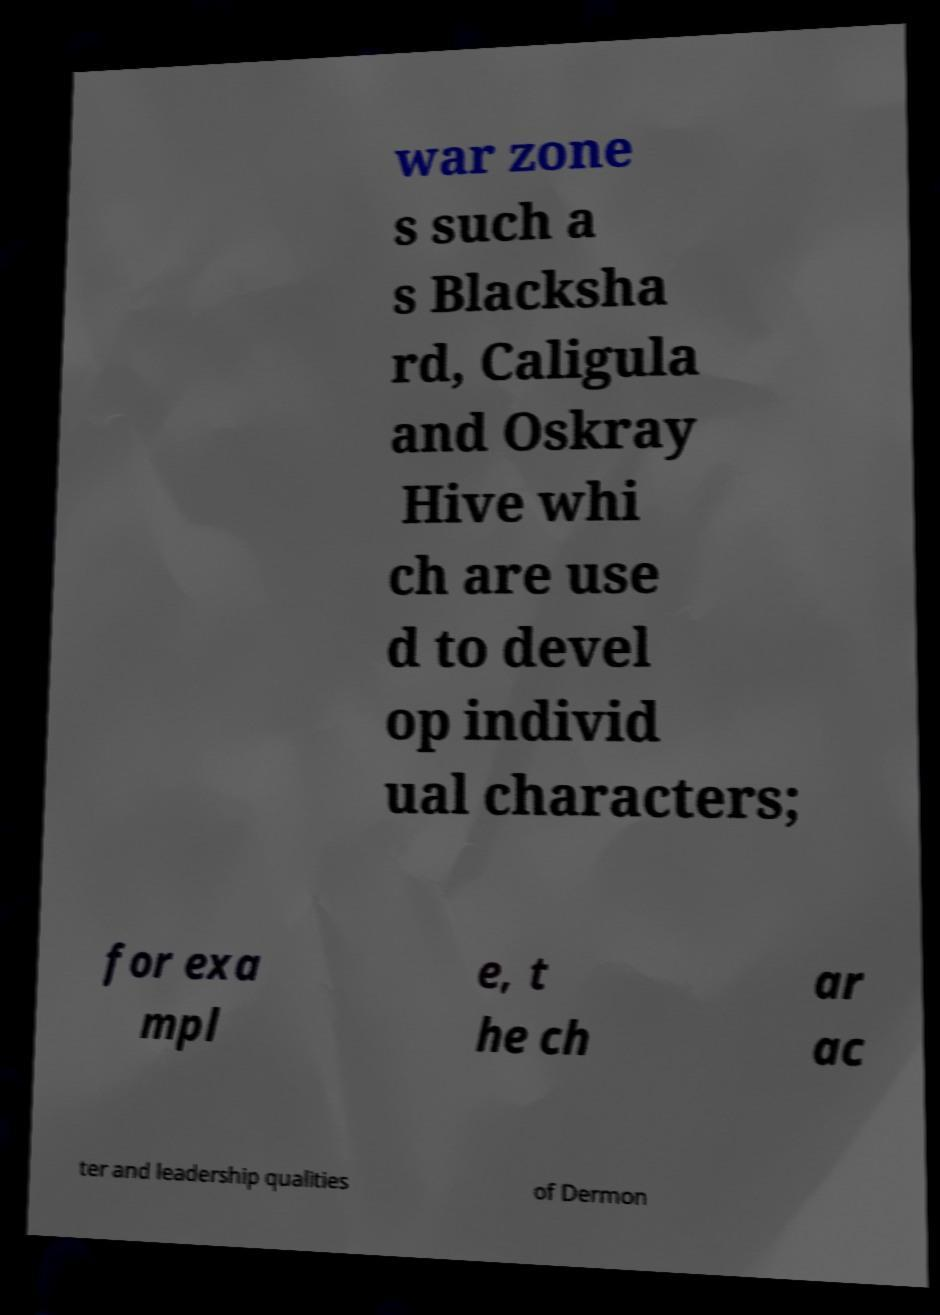For documentation purposes, I need the text within this image transcribed. Could you provide that? war zone s such a s Blacksha rd, Caligula and Oskray Hive whi ch are use d to devel op individ ual characters; for exa mpl e, t he ch ar ac ter and leadership qualities of Dermon 